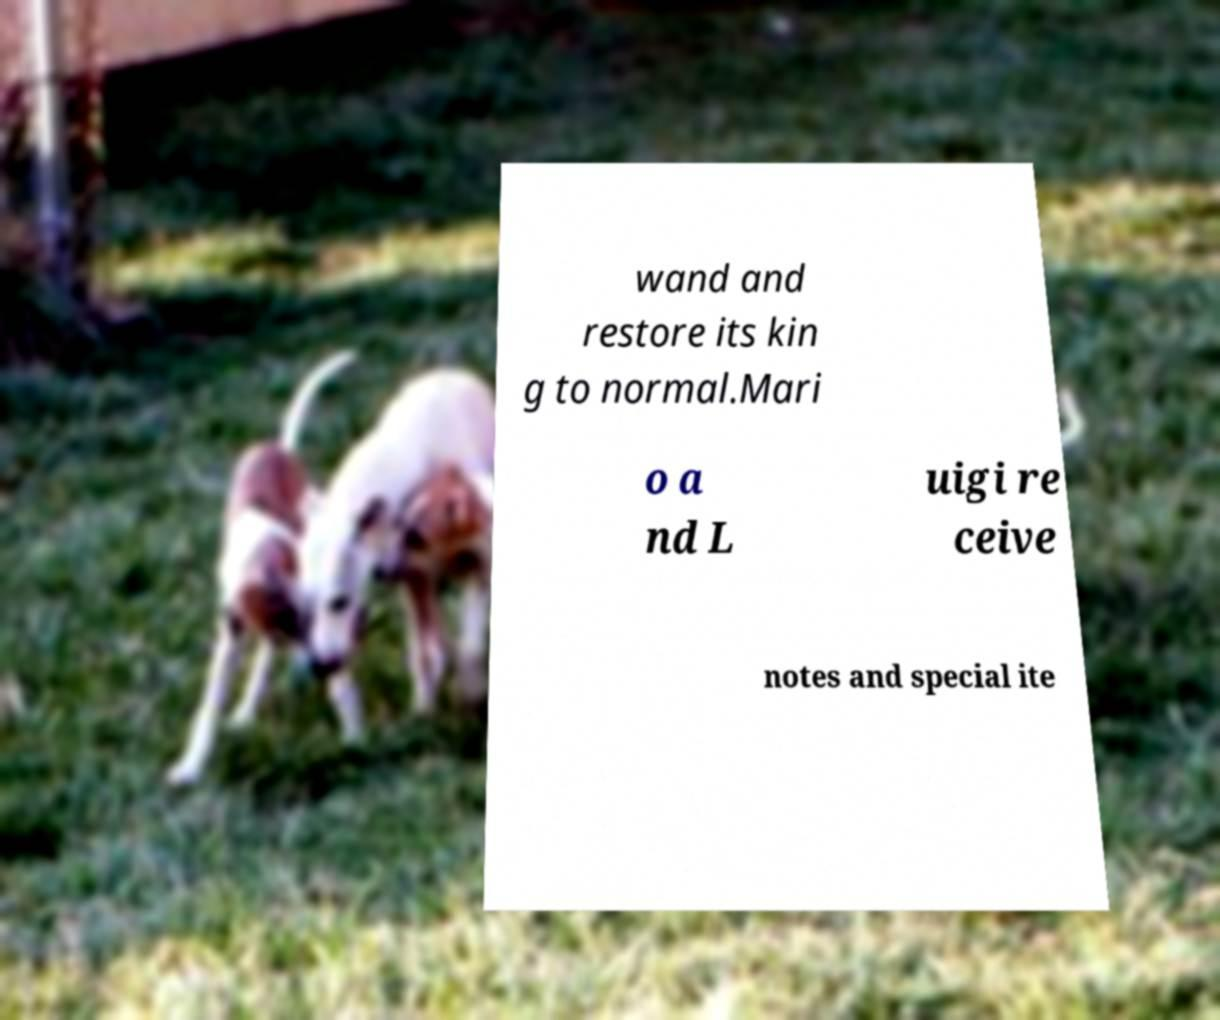Can you accurately transcribe the text from the provided image for me? wand and restore its kin g to normal.Mari o a nd L uigi re ceive notes and special ite 